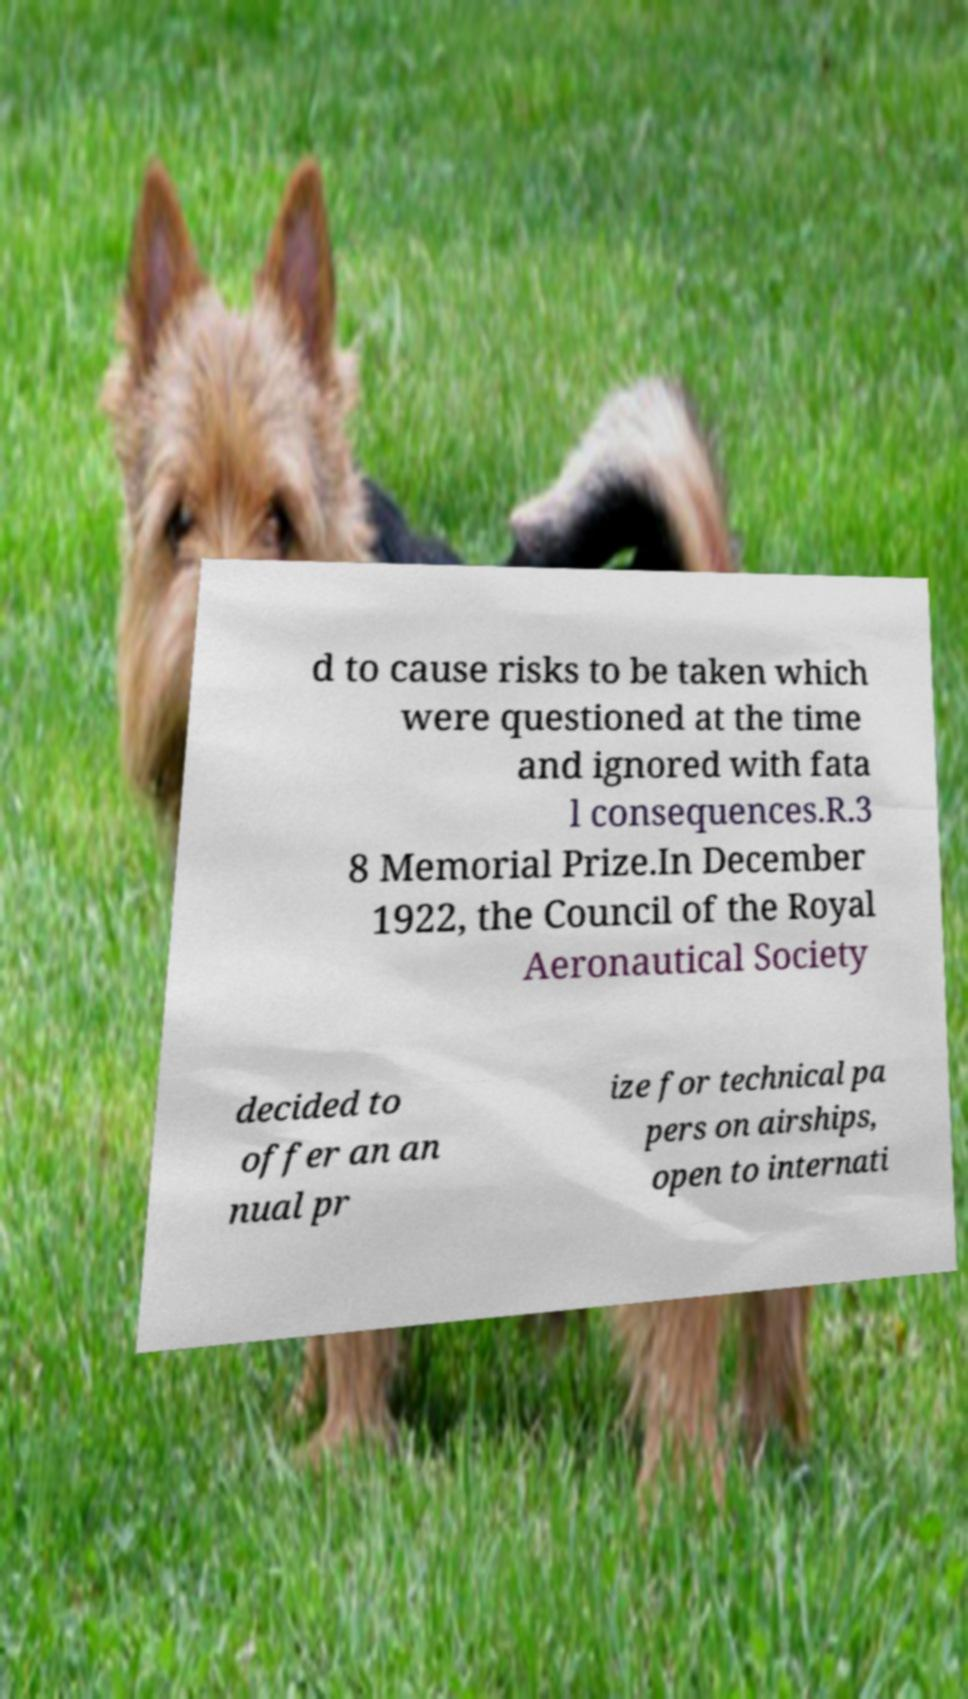Can you accurately transcribe the text from the provided image for me? d to cause risks to be taken which were questioned at the time and ignored with fata l consequences.R.3 8 Memorial Prize.In December 1922, the Council of the Royal Aeronautical Society decided to offer an an nual pr ize for technical pa pers on airships, open to internati 